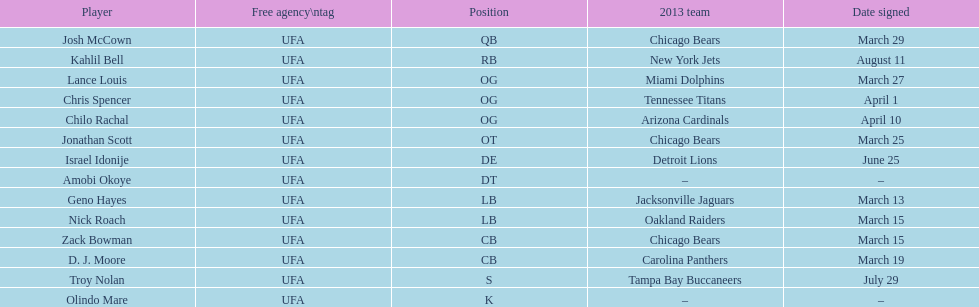Total number of players that signed in march? 7. 